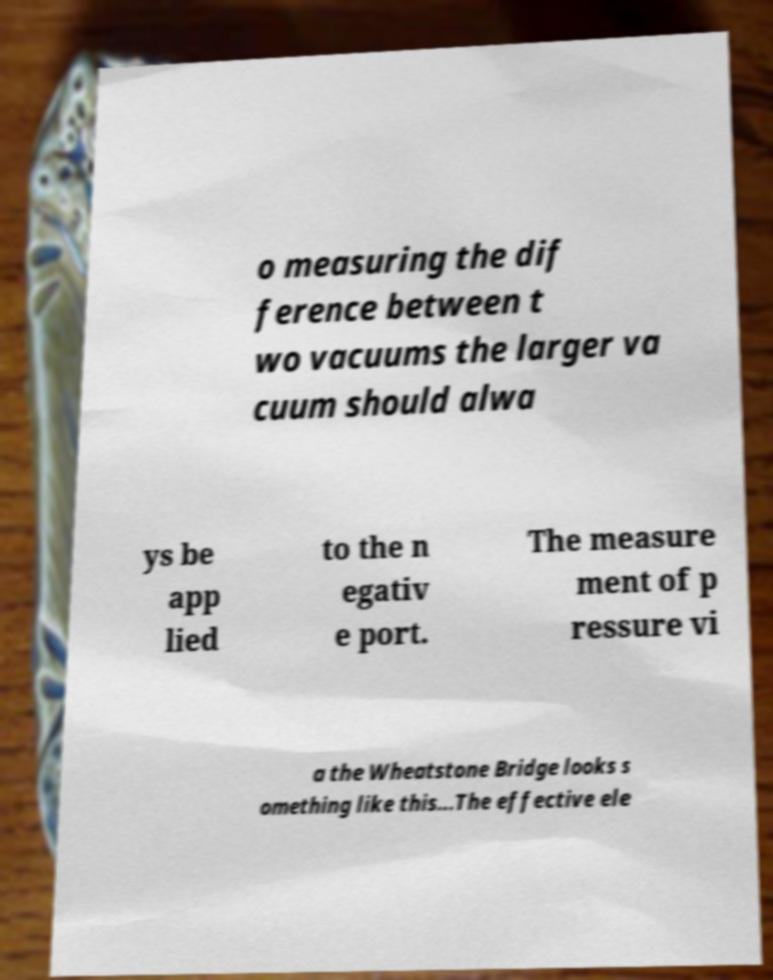What messages or text are displayed in this image? I need them in a readable, typed format. o measuring the dif ference between t wo vacuums the larger va cuum should alwa ys be app lied to the n egativ e port. The measure ment of p ressure vi a the Wheatstone Bridge looks s omething like this...The effective ele 